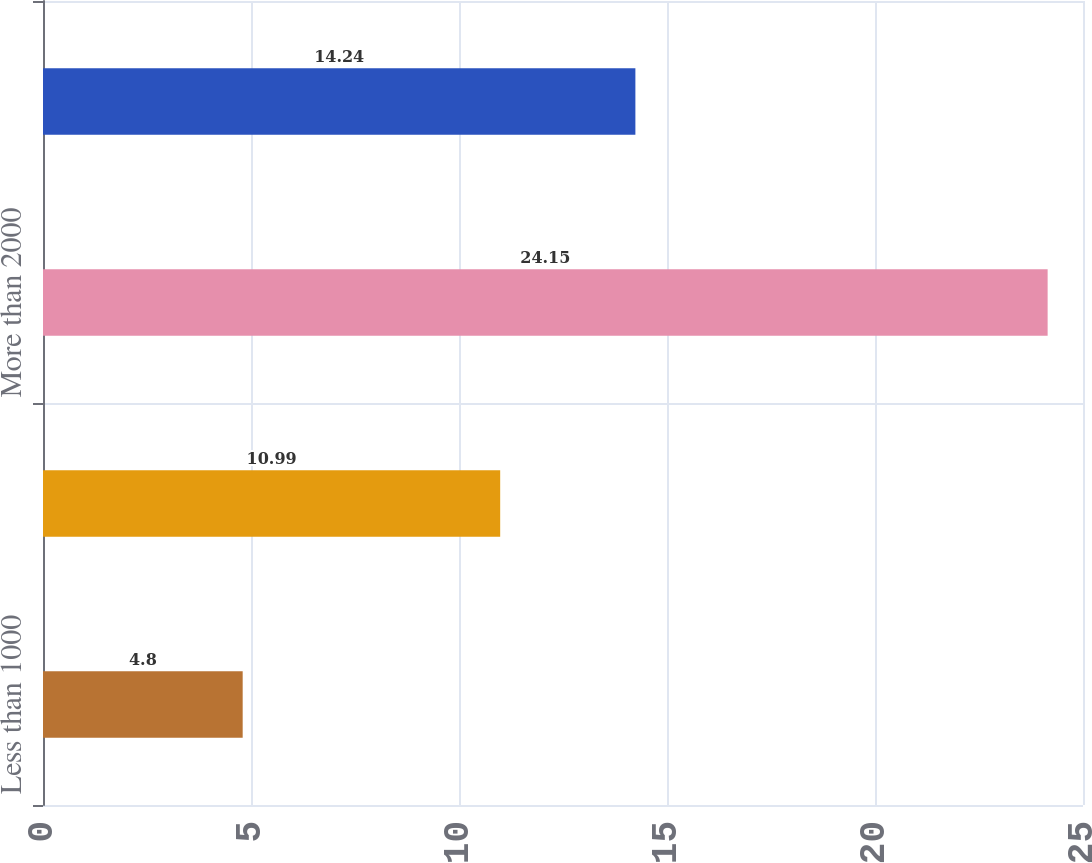Convert chart to OTSL. <chart><loc_0><loc_0><loc_500><loc_500><bar_chart><fcel>Less than 1000<fcel>1000-2000<fcel>More than 2000<fcel>Total<nl><fcel>4.8<fcel>10.99<fcel>24.15<fcel>14.24<nl></chart> 